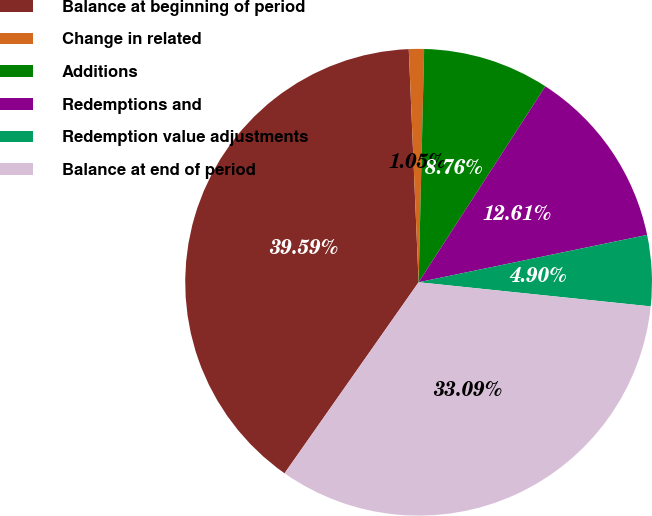Convert chart to OTSL. <chart><loc_0><loc_0><loc_500><loc_500><pie_chart><fcel>Balance at beginning of period<fcel>Change in related<fcel>Additions<fcel>Redemptions and<fcel>Redemption value adjustments<fcel>Balance at end of period<nl><fcel>39.59%<fcel>1.05%<fcel>8.76%<fcel>12.61%<fcel>4.9%<fcel>33.09%<nl></chart> 